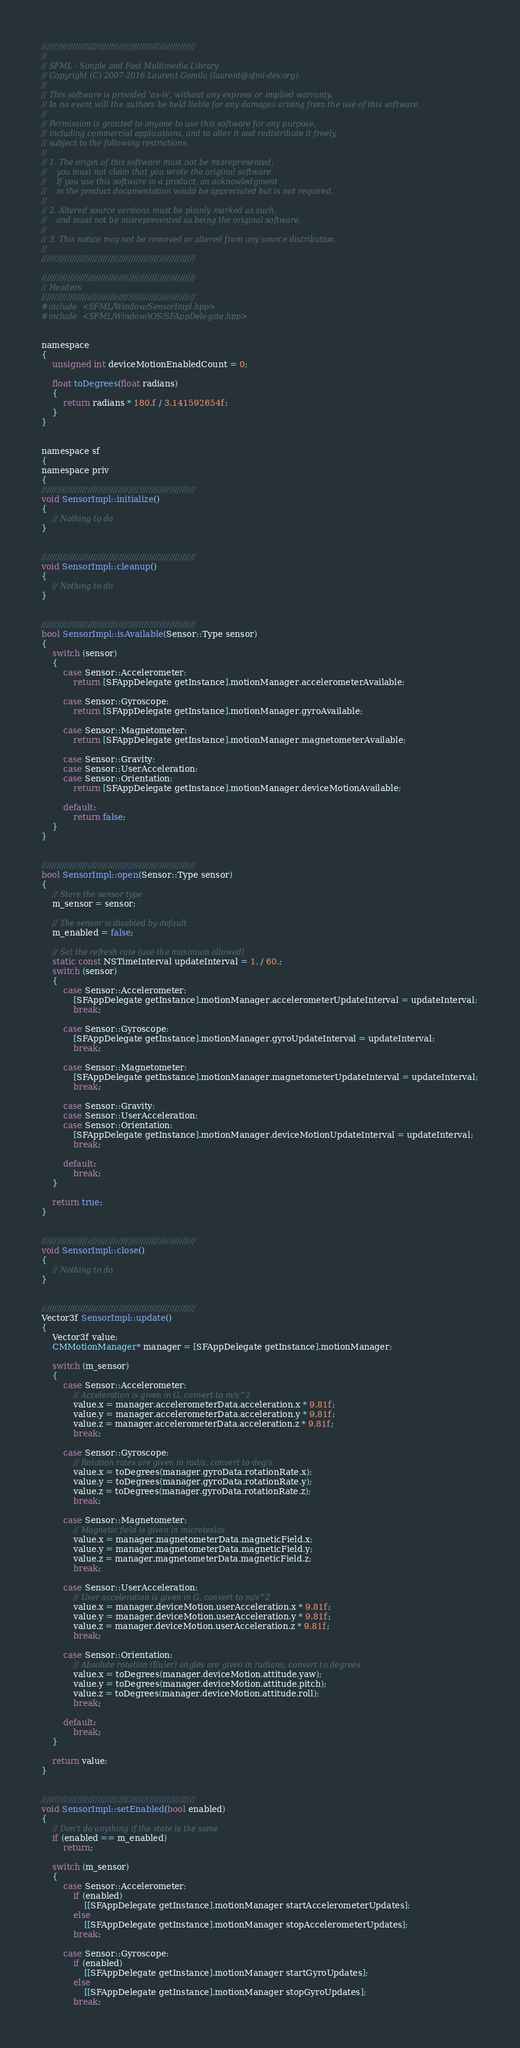Convert code to text. <code><loc_0><loc_0><loc_500><loc_500><_ObjectiveC_>////////////////////////////////////////////////////////////
//
// SFML - Simple and Fast Multimedia Library
// Copyright (C) 2007-2016 Laurent Gomila (laurent@sfml-dev.org)
//
// This software is provided 'as-is', without any express or implied warranty.
// In no event will the authors be held liable for any damages arising from the use of this software.
//
// Permission is granted to anyone to use this software for any purpose,
// including commercial applications, and to alter it and redistribute it freely,
// subject to the following restrictions:
//
// 1. The origin of this software must not be misrepresented;
//    you must not claim that you wrote the original software.
//    If you use this software in a product, an acknowledgment
//    in the product documentation would be appreciated but is not required.
//
// 2. Altered source versions must be plainly marked as such,
//    and must not be misrepresented as being the original software.
//
// 3. This notice may not be removed or altered from any source distribution.
//
////////////////////////////////////////////////////////////

////////////////////////////////////////////////////////////
// Headers
////////////////////////////////////////////////////////////
#include <SFML/Window/SensorImpl.hpp>
#include <SFML/Window/iOS/SFAppDelegate.hpp>


namespace
{
    unsigned int deviceMotionEnabledCount = 0;

    float toDegrees(float radians)
    {
        return radians * 180.f / 3.141592654f;
    }
}


namespace sf
{
namespace priv
{
////////////////////////////////////////////////////////////
void SensorImpl::initialize()
{
    // Nothing to do
}


////////////////////////////////////////////////////////////
void SensorImpl::cleanup()
{
    // Nothing to do
}


////////////////////////////////////////////////////////////
bool SensorImpl::isAvailable(Sensor::Type sensor)
{
    switch (sensor)
    {
        case Sensor::Accelerometer:
            return [SFAppDelegate getInstance].motionManager.accelerometerAvailable;

        case Sensor::Gyroscope:
            return [SFAppDelegate getInstance].motionManager.gyroAvailable;

        case Sensor::Magnetometer:
            return [SFAppDelegate getInstance].motionManager.magnetometerAvailable;

        case Sensor::Gravity:
        case Sensor::UserAcceleration:
        case Sensor::Orientation:
            return [SFAppDelegate getInstance].motionManager.deviceMotionAvailable;

        default:
            return false;
    }
}


////////////////////////////////////////////////////////////
bool SensorImpl::open(Sensor::Type sensor)
{
    // Store the sensor type
    m_sensor = sensor;

    // The sensor is disabled by default
    m_enabled = false;

    // Set the refresh rate (use the maximum allowed)
    static const NSTimeInterval updateInterval = 1. / 60.;
    switch (sensor)
    {
        case Sensor::Accelerometer:
            [SFAppDelegate getInstance].motionManager.accelerometerUpdateInterval = updateInterval;
            break;

        case Sensor::Gyroscope:
            [SFAppDelegate getInstance].motionManager.gyroUpdateInterval = updateInterval;
            break;

        case Sensor::Magnetometer:
            [SFAppDelegate getInstance].motionManager.magnetometerUpdateInterval = updateInterval;
            break;

        case Sensor::Gravity:
        case Sensor::UserAcceleration:
        case Sensor::Orientation:
            [SFAppDelegate getInstance].motionManager.deviceMotionUpdateInterval = updateInterval;
            break;

        default:
            break;
    }

    return true;
}


////////////////////////////////////////////////////////////
void SensorImpl::close()
{
    // Nothing to do
}


////////////////////////////////////////////////////////////
Vector3f SensorImpl::update()
{
    Vector3f value;
    CMMotionManager* manager = [SFAppDelegate getInstance].motionManager;

    switch (m_sensor)
    {
        case Sensor::Accelerometer:
            // Acceleration is given in G, convert to m/s^2
            value.x = manager.accelerometerData.acceleration.x * 9.81f;
            value.y = manager.accelerometerData.acceleration.y * 9.81f;
            value.z = manager.accelerometerData.acceleration.z * 9.81f;
            break;

        case Sensor::Gyroscope:
            // Rotation rates are given in rad/s, convert to deg/s
            value.x = toDegrees(manager.gyroData.rotationRate.x);
            value.y = toDegrees(manager.gyroData.rotationRate.y);
            value.z = toDegrees(manager.gyroData.rotationRate.z);
            break;

        case Sensor::Magnetometer:
            // Magnetic field is given in microteslas
            value.x = manager.magnetometerData.magneticField.x;
            value.y = manager.magnetometerData.magneticField.y;
            value.z = manager.magnetometerData.magneticField.z;
            break;

        case Sensor::UserAcceleration:
            // User acceleration is given in G, convert to m/s^2
            value.x = manager.deviceMotion.userAcceleration.x * 9.81f;
            value.y = manager.deviceMotion.userAcceleration.y * 9.81f;
            value.z = manager.deviceMotion.userAcceleration.z * 9.81f;
            break;

        case Sensor::Orientation:
            // Absolute rotation (Euler) angles are given in radians, convert to degrees
            value.x = toDegrees(manager.deviceMotion.attitude.yaw);
            value.y = toDegrees(manager.deviceMotion.attitude.pitch);
            value.z = toDegrees(manager.deviceMotion.attitude.roll);
            break;

        default:
            break;
    }

    return value;
}


////////////////////////////////////////////////////////////
void SensorImpl::setEnabled(bool enabled)
{
    // Don't do anything if the state is the same
    if (enabled == m_enabled)
        return;

    switch (m_sensor)
    {
        case Sensor::Accelerometer:
            if (enabled)
                [[SFAppDelegate getInstance].motionManager startAccelerometerUpdates];
            else
                [[SFAppDelegate getInstance].motionManager stopAccelerometerUpdates];
            break;

        case Sensor::Gyroscope:
            if (enabled)
                [[SFAppDelegate getInstance].motionManager startGyroUpdates];
            else
                [[SFAppDelegate getInstance].motionManager stopGyroUpdates];
            break;
</code> 